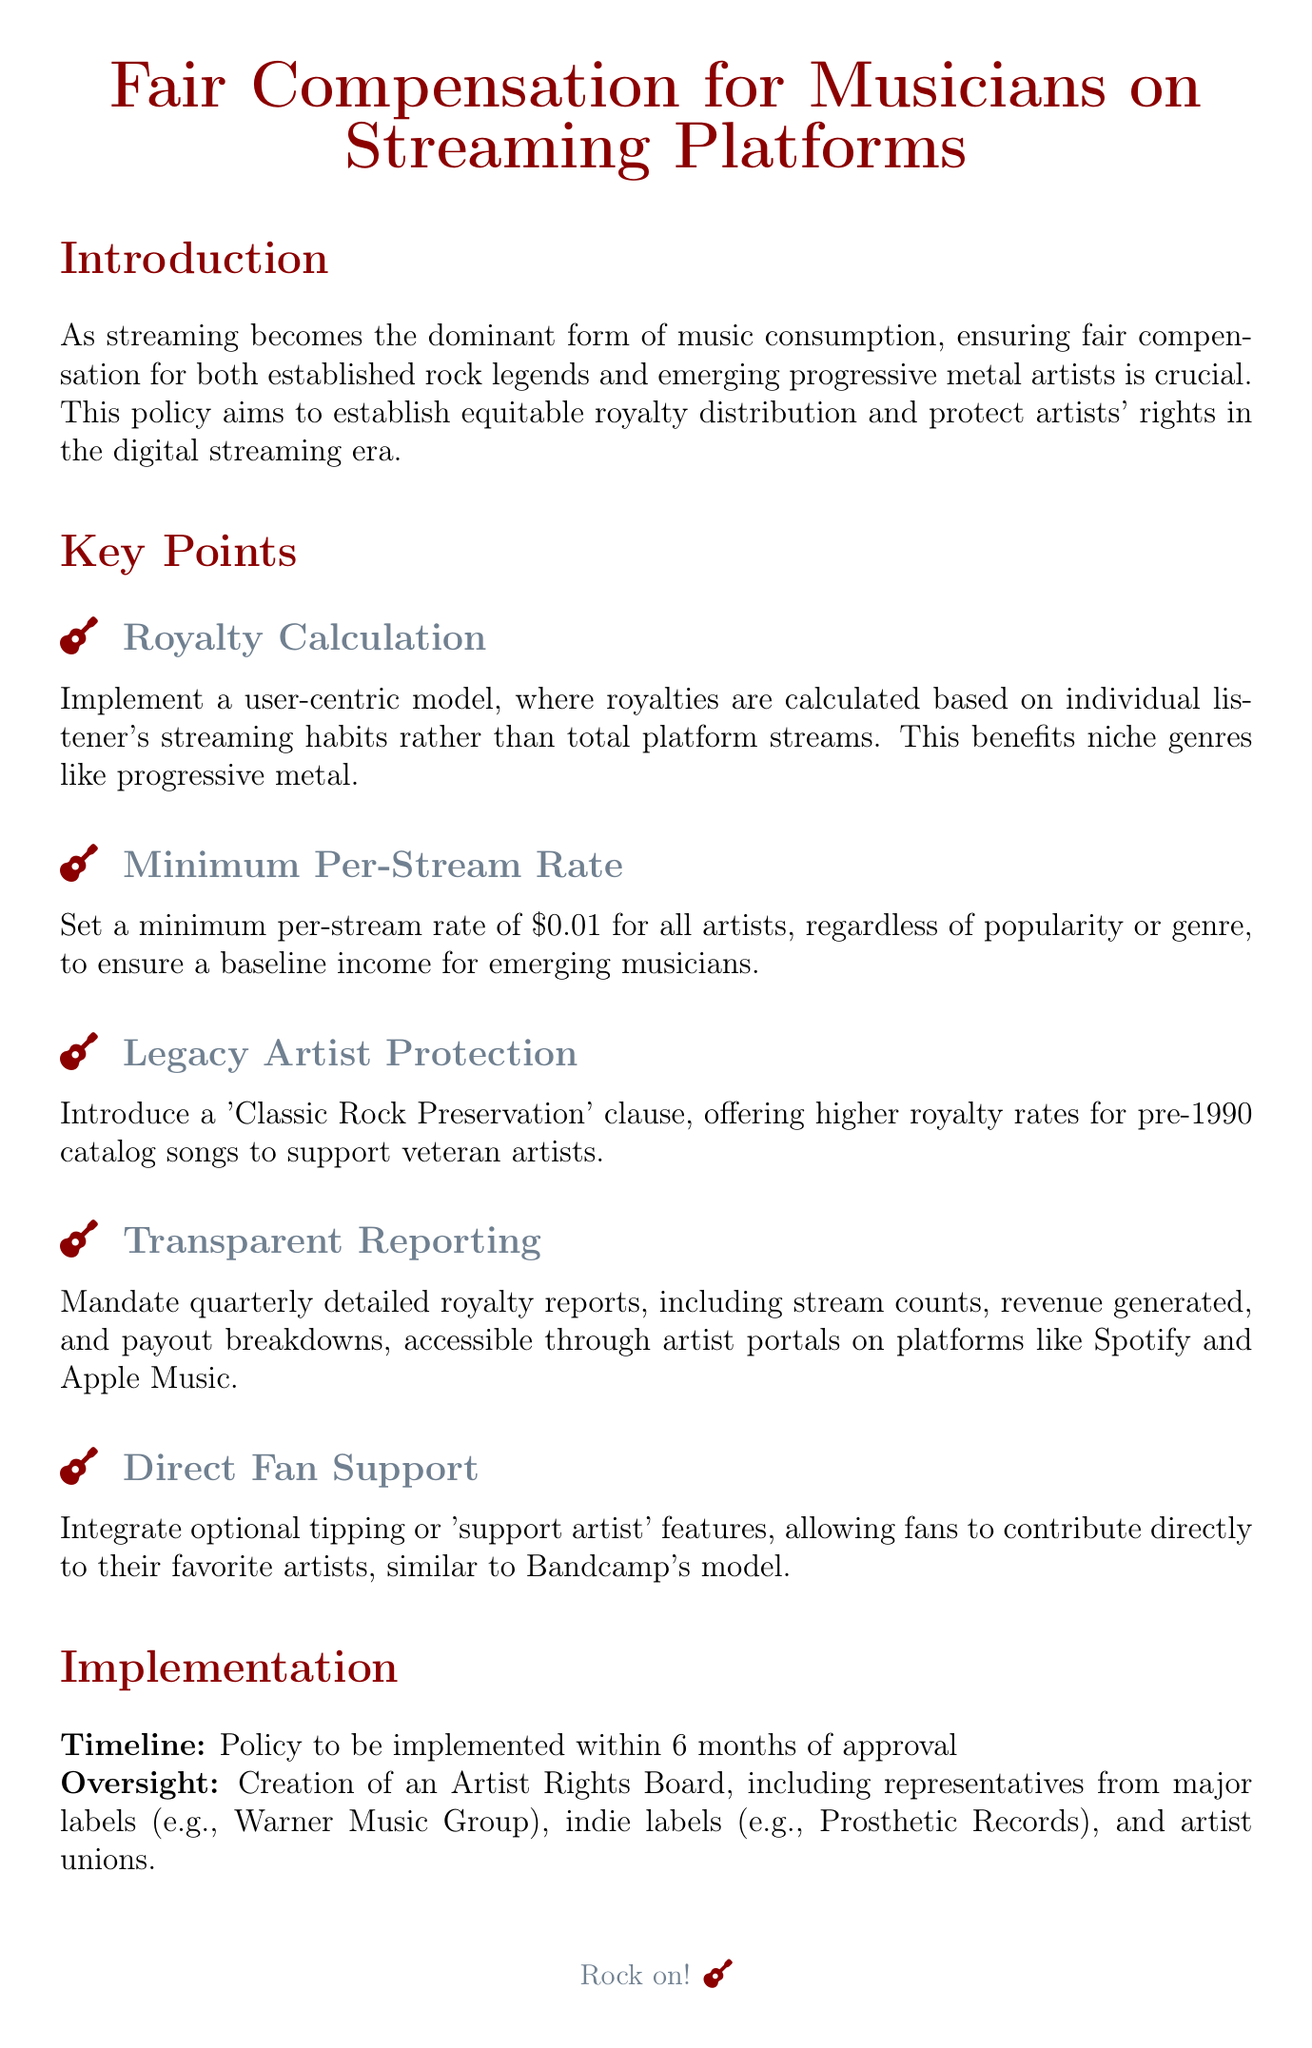What is the minimum per-stream rate? The document states that the minimum per-stream rate is set to ensure a basic income for emerging musicians.
Answer: $0.01 What is the main goal of the policy? The main goal of the policy is to ensure fair compensation for both established and emerging musicians in the streaming landscape.
Answer: Fair compensation Who is responsible for oversight of the policy? The oversight involves the creation of an Artist Rights Board with representatives from various sectors of the music industry.
Answer: Artist Rights Board What feature allows direct fan support for musicians? The document mentions an integration for fans to directly contribute to their favorite artists.
Answer: Support artist What is a benefit of the user-centric model for royalty calculation? This model is designed to benefit niche genres, like progressive metal, by basing royalties on individual listener habits.
Answer: Niche genres What clause is included to protect legacy artists? The document includes a specific clause aimed at supporting veteran artists through higher royalty rates.
Answer: Classic Rock Preservation How often will detailed royalty reports be provided? The policy mandates a specific frequency for reporting royalties to the artists.
Answer: Quarterly What is the timeline for policy implementation? The policy stipulates a specific time frame for when it will be enacted following approval.
Answer: 6 months 